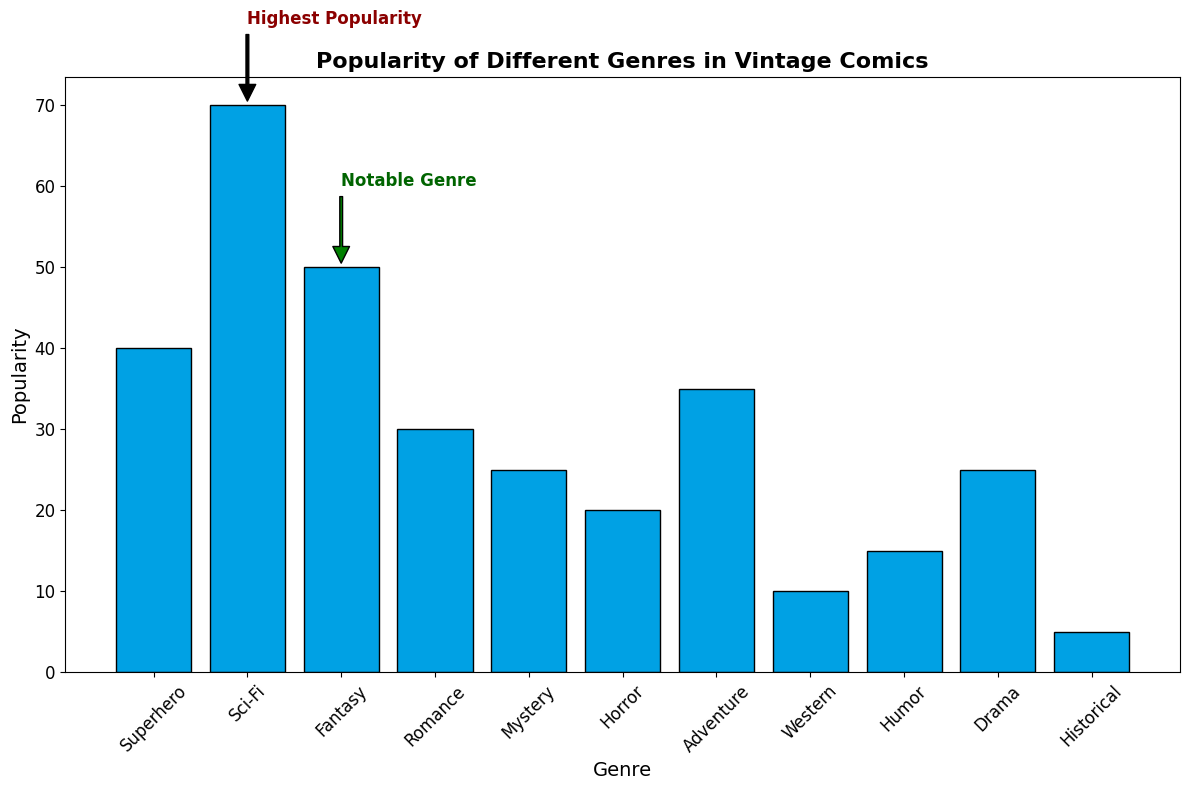What genre has the highest popularity according to the plot? The annotations and the height of the bars show that the Sci-Fi genre has the highest popularity among all the genres.
Answer: Sci-Fi Which genre is highlighted as the 'Notable Genre' in the plot? The text annotation "Notable Genre" is specifically pointing to the Fantasy genre bar.
Answer: Fantasy Compare the popularity of the Adventure and Mystery genres. Which one is more popular and by how much? The bar heights show Adventure at 35 and Mystery at 25. The difference in popularity is 35 - 25 = 10.
Answer: Adventure by 10 What is the combined popularity of the genres Sci-Fi, Fantasy, and Horror? By summing the individual popularity values: Sci-Fi (70) + Fantasy (50) + Horror (20) = 140.
Answer: 140 What is the ratio of the popularity of Superhero to Romance genres? The popularity of Superhero is 40 and Romance is 30. The ratio is 40:30, which simplifies to 4:3.
Answer: 4:3 How does the popularity of Western compare to Historical genres? Western has a popularity of 10, and Historical has a popularity of 5. Western is twice as popular as Historical.
Answer: Western is twice as popular What is the average popularity of all genres? Summing all popularity values: 40 + 70 + 50 + 30 + 25 + 20 + 35 + 10 + 15 + 25 + 5 = 325. The number of genres is 11. The average is 325 / 11 ≈ 29.55.
Answer: ≈ 29.55 If you were to exclude Sci-Fi and Fantasy genres, what would the new average popularity be? Excluding Sci-Fi (70) and Fantasy (50), the sum of the remaining popularity values: 40 + 30 + 25 + 20 + 35 + 10 + 15 + 25 + 5 = 205. The number of remaining genres is 9. The new average is 205 / 9 ≈ 22.78.
Answer: ≈ 22.78 Which genres have a popularity less than the average popularity of all genres? The average popularity is approximately 29.55. Genres less than this are Romance (30 is not less), Mystery (25), Horror (20), Western (10), Humor (15), Drama (25), and Historical (5).
Answer: Mystery, Horror, Western, Humor, Drama, Historical Among the genres with popularity higher than 30, which genre has the least popularity and what is that value? Genres with popularity higher than 30 are Superhero (40), Sci-Fi (70), Fantasy (50), and Adventure (35). Adventure has the least popularity among them with a value of 35.
Answer: Adventure with 35 